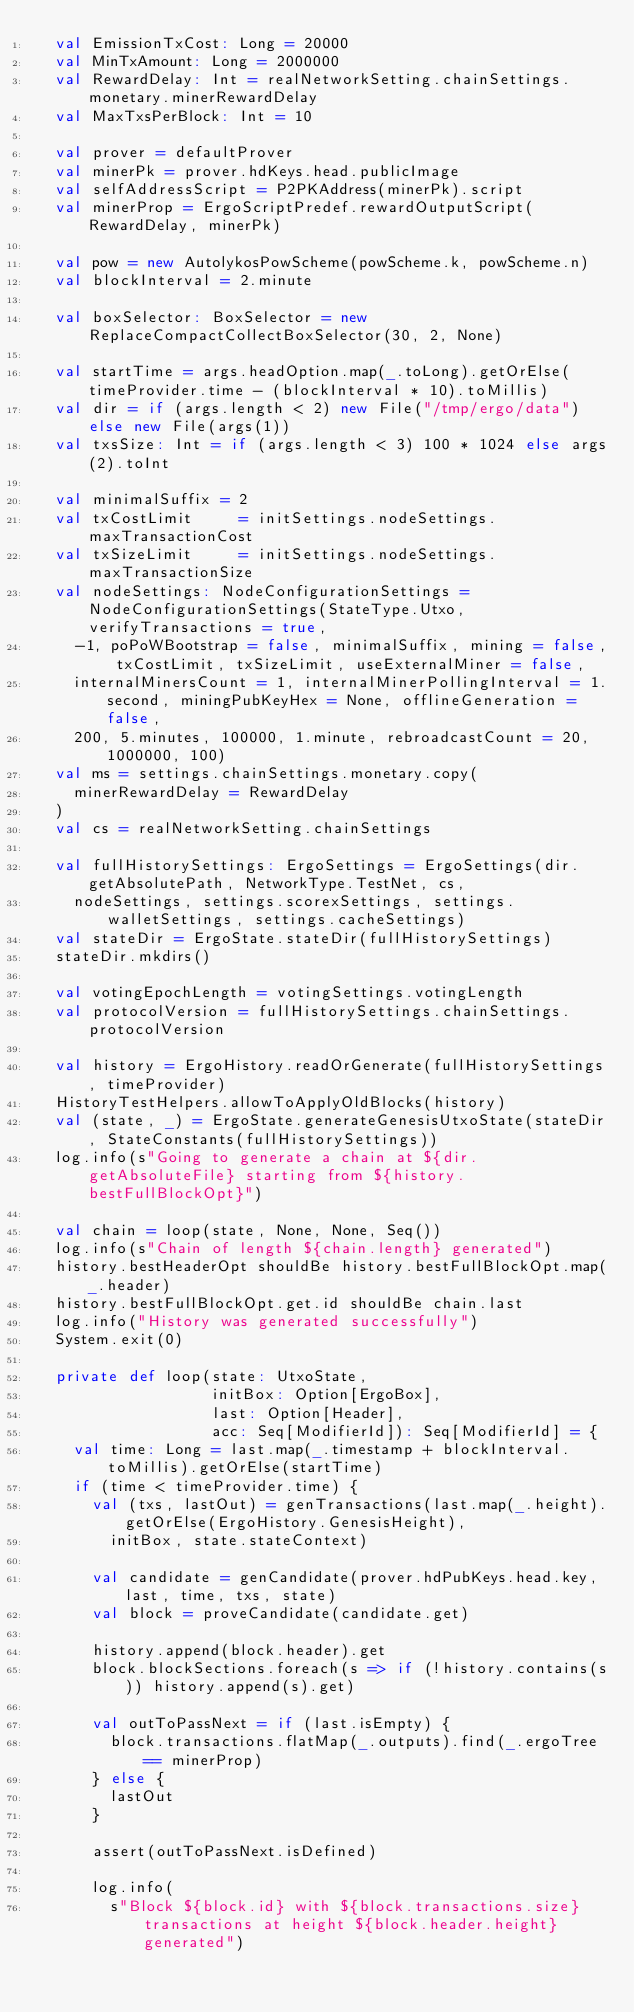Convert code to text. <code><loc_0><loc_0><loc_500><loc_500><_Scala_>  val EmissionTxCost: Long = 20000
  val MinTxAmount: Long = 2000000
  val RewardDelay: Int = realNetworkSetting.chainSettings.monetary.minerRewardDelay
  val MaxTxsPerBlock: Int = 10

  val prover = defaultProver
  val minerPk = prover.hdKeys.head.publicImage
  val selfAddressScript = P2PKAddress(minerPk).script
  val minerProp = ErgoScriptPredef.rewardOutputScript(RewardDelay, minerPk)

  val pow = new AutolykosPowScheme(powScheme.k, powScheme.n)
  val blockInterval = 2.minute

  val boxSelector: BoxSelector = new ReplaceCompactCollectBoxSelector(30, 2, None)

  val startTime = args.headOption.map(_.toLong).getOrElse(timeProvider.time - (blockInterval * 10).toMillis)
  val dir = if (args.length < 2) new File("/tmp/ergo/data") else new File(args(1))
  val txsSize: Int = if (args.length < 3) 100 * 1024 else args(2).toInt

  val minimalSuffix = 2
  val txCostLimit     = initSettings.nodeSettings.maxTransactionCost
  val txSizeLimit     = initSettings.nodeSettings.maxTransactionSize
  val nodeSettings: NodeConfigurationSettings = NodeConfigurationSettings(StateType.Utxo, verifyTransactions = true,
    -1, poPoWBootstrap = false, minimalSuffix, mining = false, txCostLimit, txSizeLimit, useExternalMiner = false,
    internalMinersCount = 1, internalMinerPollingInterval = 1.second, miningPubKeyHex = None, offlineGeneration = false,
    200, 5.minutes, 100000, 1.minute, rebroadcastCount = 20, 1000000, 100)
  val ms = settings.chainSettings.monetary.copy(
    minerRewardDelay = RewardDelay
  )
  val cs = realNetworkSetting.chainSettings

  val fullHistorySettings: ErgoSettings = ErgoSettings(dir.getAbsolutePath, NetworkType.TestNet, cs,
    nodeSettings, settings.scorexSettings, settings.walletSettings, settings.cacheSettings)
  val stateDir = ErgoState.stateDir(fullHistorySettings)
  stateDir.mkdirs()

  val votingEpochLength = votingSettings.votingLength
  val protocolVersion = fullHistorySettings.chainSettings.protocolVersion

  val history = ErgoHistory.readOrGenerate(fullHistorySettings, timeProvider)
  HistoryTestHelpers.allowToApplyOldBlocks(history)
  val (state, _) = ErgoState.generateGenesisUtxoState(stateDir, StateConstants(fullHistorySettings))
  log.info(s"Going to generate a chain at ${dir.getAbsoluteFile} starting from ${history.bestFullBlockOpt}")

  val chain = loop(state, None, None, Seq())
  log.info(s"Chain of length ${chain.length} generated")
  history.bestHeaderOpt shouldBe history.bestFullBlockOpt.map(_.header)
  history.bestFullBlockOpt.get.id shouldBe chain.last
  log.info("History was generated successfully")
  System.exit(0)

  private def loop(state: UtxoState,
                   initBox: Option[ErgoBox],
                   last: Option[Header],
                   acc: Seq[ModifierId]): Seq[ModifierId] = {
    val time: Long = last.map(_.timestamp + blockInterval.toMillis).getOrElse(startTime)
    if (time < timeProvider.time) {
      val (txs, lastOut) = genTransactions(last.map(_.height).getOrElse(ErgoHistory.GenesisHeight),
        initBox, state.stateContext)

      val candidate = genCandidate(prover.hdPubKeys.head.key, last, time, txs, state)
      val block = proveCandidate(candidate.get)

      history.append(block.header).get
      block.blockSections.foreach(s => if (!history.contains(s)) history.append(s).get)

      val outToPassNext = if (last.isEmpty) {
        block.transactions.flatMap(_.outputs).find(_.ergoTree == minerProp)
      } else {
        lastOut
      }

      assert(outToPassNext.isDefined)

      log.info(
        s"Block ${block.id} with ${block.transactions.size} transactions at height ${block.header.height} generated")
</code> 